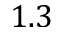<formula> <loc_0><loc_0><loc_500><loc_500>1 . 3</formula> 